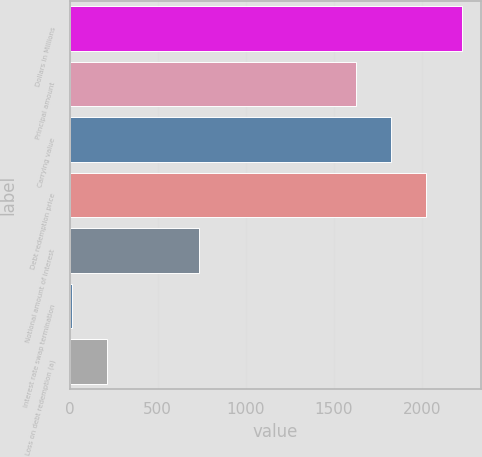Convert chart to OTSL. <chart><loc_0><loc_0><loc_500><loc_500><bar_chart><fcel>Dollars in Millions<fcel>Principal amount<fcel>Carrying value<fcel>Debt redemption price<fcel>Notional amount of interest<fcel>Interest rate swap termination<fcel>Loss on debt redemption (a)<nl><fcel>2225.2<fcel>1624<fcel>1824.4<fcel>2024.8<fcel>735<fcel>11<fcel>211.4<nl></chart> 